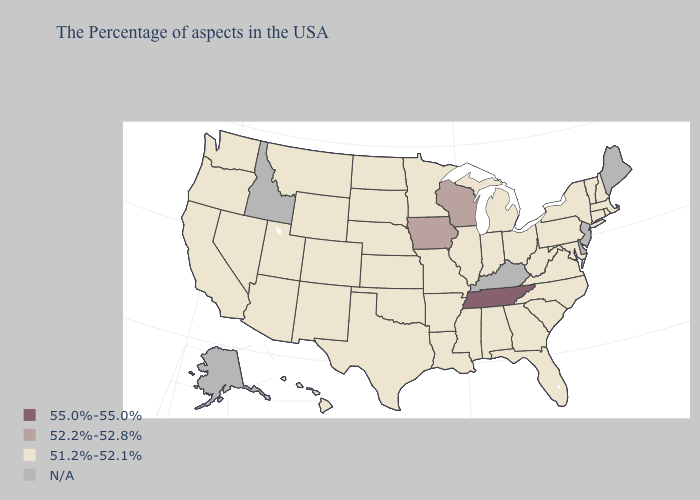What is the highest value in the West ?
Write a very short answer. 51.2%-52.1%. Name the states that have a value in the range N/A?
Short answer required. Maine, New Jersey, Delaware, Kentucky, Idaho, Alaska. Which states have the lowest value in the South?
Short answer required. Maryland, Virginia, North Carolina, South Carolina, West Virginia, Florida, Georgia, Alabama, Mississippi, Louisiana, Arkansas, Oklahoma, Texas. Name the states that have a value in the range 52.2%-52.8%?
Answer briefly. Wisconsin, Iowa. What is the highest value in the South ?
Be succinct. 55.0%-55.0%. Does Iowa have the lowest value in the USA?
Concise answer only. No. What is the value of Hawaii?
Short answer required. 51.2%-52.1%. Name the states that have a value in the range 51.2%-52.1%?
Give a very brief answer. Massachusetts, Rhode Island, New Hampshire, Vermont, Connecticut, New York, Maryland, Pennsylvania, Virginia, North Carolina, South Carolina, West Virginia, Ohio, Florida, Georgia, Michigan, Indiana, Alabama, Illinois, Mississippi, Louisiana, Missouri, Arkansas, Minnesota, Kansas, Nebraska, Oklahoma, Texas, South Dakota, North Dakota, Wyoming, Colorado, New Mexico, Utah, Montana, Arizona, Nevada, California, Washington, Oregon, Hawaii. How many symbols are there in the legend?
Concise answer only. 4. What is the highest value in states that border Nevada?
Keep it brief. 51.2%-52.1%. What is the value of California?
Give a very brief answer. 51.2%-52.1%. 